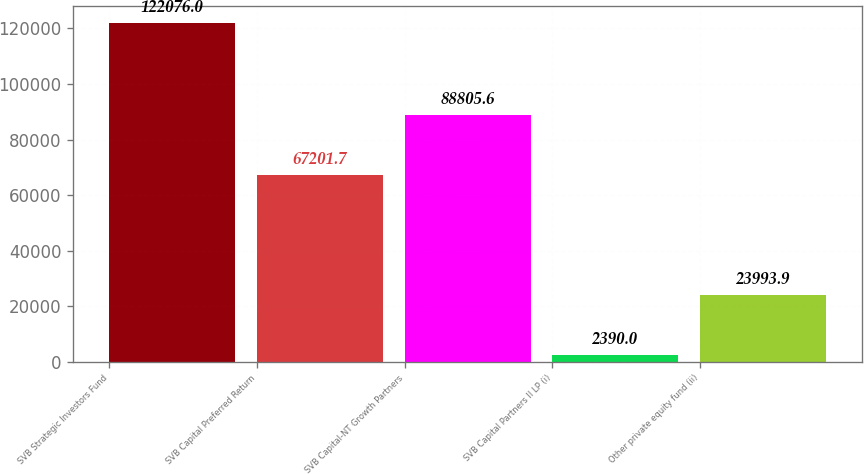Convert chart to OTSL. <chart><loc_0><loc_0><loc_500><loc_500><bar_chart><fcel>SVB Strategic Investors Fund<fcel>SVB Capital Preferred Return<fcel>SVB Capital-NT Growth Partners<fcel>SVB Capital Partners II LP (i)<fcel>Other private equity fund (ii)<nl><fcel>122076<fcel>67201.7<fcel>88805.6<fcel>2390<fcel>23993.9<nl></chart> 